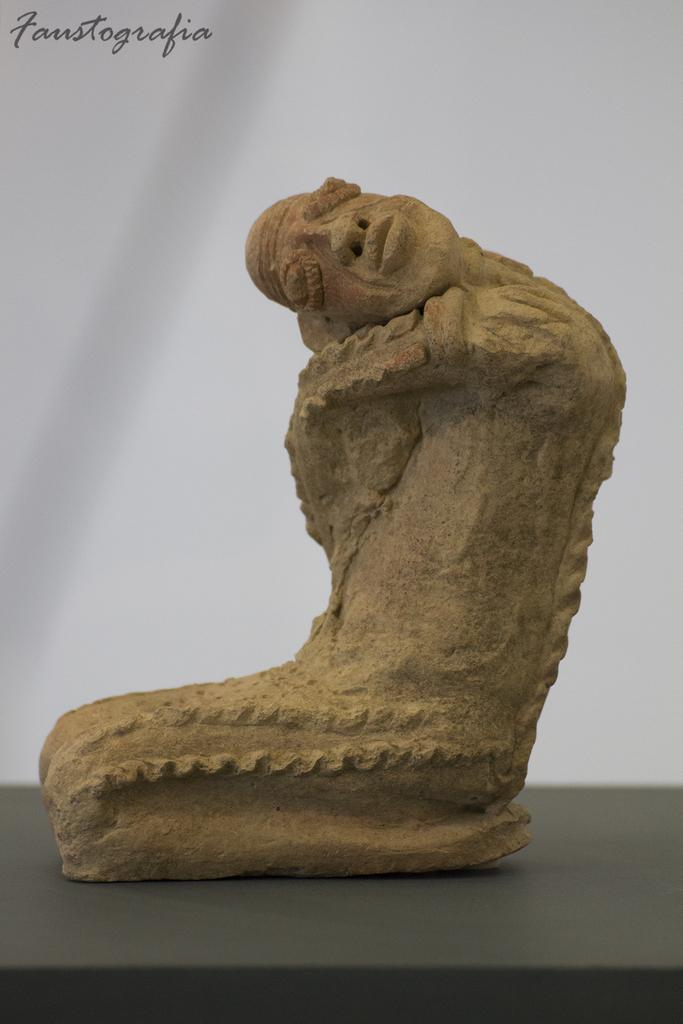What is the main subject of the image? There is a sculpture in the image. What is the color of the surface on which the sculpture is placed? The sculpture is on a black color surface. Can you describe any additional features or elements in the image? There is a watermark in the image. What is the color of the background in the image? The background of the image is white in color. What type of blade can be seen cutting through the rose in the image? There is no blade or rose present in the image; it features a sculpture on a black surface with a white background and a watermark. 